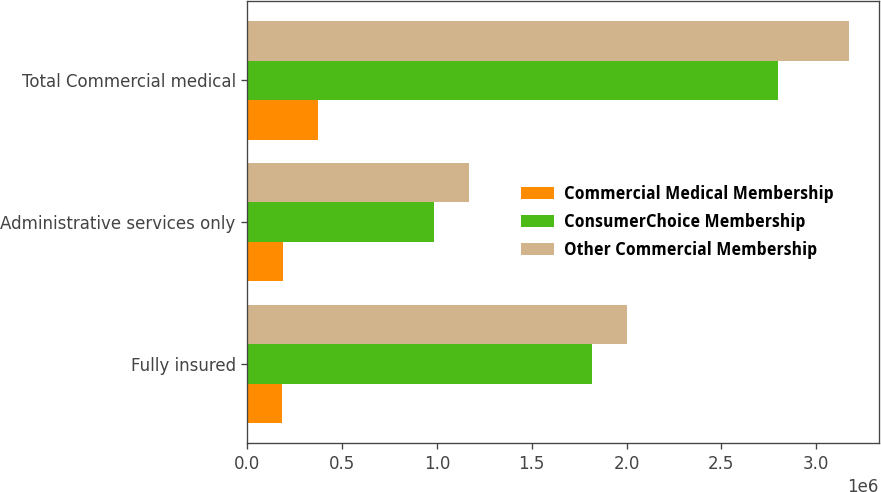<chart> <loc_0><loc_0><loc_500><loc_500><stacked_bar_chart><ecel><fcel>Fully insured<fcel>Administrative services only<fcel>Total Commercial medical<nl><fcel>Commercial Medical Membership<fcel>184000<fcel>187100<fcel>371100<nl><fcel>ConsumerChoice Membership<fcel>1.8158e+06<fcel>983900<fcel>2.7997e+06<nl><fcel>Other Commercial Membership<fcel>1.9998e+06<fcel>1.171e+06<fcel>3.1708e+06<nl></chart> 